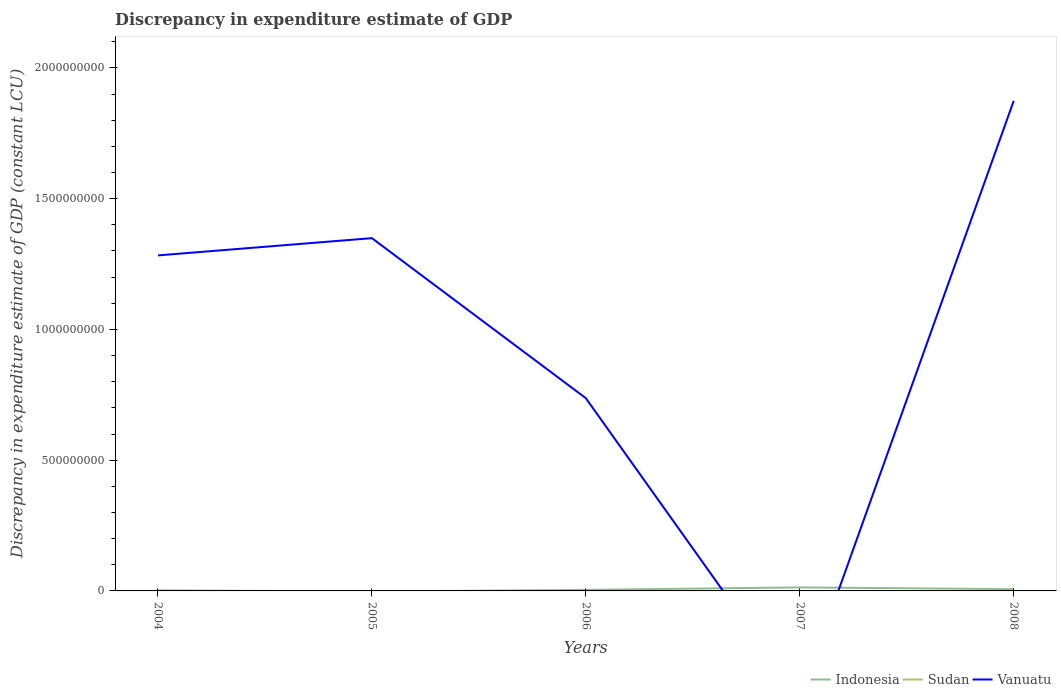Is the number of lines equal to the number of legend labels?
Your answer should be compact. No. Across all years, what is the maximum discrepancy in expenditure estimate of GDP in Sudan?
Keep it short and to the point. 0. What is the total discrepancy in expenditure estimate of GDP in Vanuatu in the graph?
Your answer should be compact. -1.14e+09. What is the difference between the highest and the second highest discrepancy in expenditure estimate of GDP in Vanuatu?
Offer a terse response. 1.87e+09. Is the discrepancy in expenditure estimate of GDP in Sudan strictly greater than the discrepancy in expenditure estimate of GDP in Vanuatu over the years?
Provide a succinct answer. Yes. How many lines are there?
Offer a very short reply. 2. How many years are there in the graph?
Provide a succinct answer. 5. What is the difference between two consecutive major ticks on the Y-axis?
Keep it short and to the point. 5.00e+08. Are the values on the major ticks of Y-axis written in scientific E-notation?
Provide a succinct answer. No. Does the graph contain any zero values?
Your response must be concise. Yes. Does the graph contain grids?
Ensure brevity in your answer.  No. What is the title of the graph?
Keep it short and to the point. Discrepancy in expenditure estimate of GDP. What is the label or title of the Y-axis?
Make the answer very short. Discrepancy in expenditure estimate of GDP (constant LCU). What is the Discrepancy in expenditure estimate of GDP (constant LCU) in Indonesia in 2004?
Give a very brief answer. 2.19e+06. What is the Discrepancy in expenditure estimate of GDP (constant LCU) in Vanuatu in 2004?
Give a very brief answer. 1.28e+09. What is the Discrepancy in expenditure estimate of GDP (constant LCU) of Vanuatu in 2005?
Provide a succinct answer. 1.35e+09. What is the Discrepancy in expenditure estimate of GDP (constant LCU) of Indonesia in 2006?
Offer a terse response. 4.05e+06. What is the Discrepancy in expenditure estimate of GDP (constant LCU) of Sudan in 2006?
Your answer should be very brief. 0. What is the Discrepancy in expenditure estimate of GDP (constant LCU) in Vanuatu in 2006?
Offer a very short reply. 7.37e+08. What is the Discrepancy in expenditure estimate of GDP (constant LCU) in Indonesia in 2007?
Your answer should be compact. 1.35e+07. What is the Discrepancy in expenditure estimate of GDP (constant LCU) in Indonesia in 2008?
Provide a succinct answer. 6.75e+06. What is the Discrepancy in expenditure estimate of GDP (constant LCU) of Sudan in 2008?
Offer a terse response. 0. What is the Discrepancy in expenditure estimate of GDP (constant LCU) in Vanuatu in 2008?
Provide a succinct answer. 1.87e+09. Across all years, what is the maximum Discrepancy in expenditure estimate of GDP (constant LCU) of Indonesia?
Offer a terse response. 1.35e+07. Across all years, what is the maximum Discrepancy in expenditure estimate of GDP (constant LCU) of Vanuatu?
Give a very brief answer. 1.87e+09. Across all years, what is the minimum Discrepancy in expenditure estimate of GDP (constant LCU) in Indonesia?
Provide a succinct answer. 0. What is the total Discrepancy in expenditure estimate of GDP (constant LCU) in Indonesia in the graph?
Your answer should be very brief. 2.65e+07. What is the total Discrepancy in expenditure estimate of GDP (constant LCU) in Sudan in the graph?
Provide a succinct answer. 0. What is the total Discrepancy in expenditure estimate of GDP (constant LCU) in Vanuatu in the graph?
Your answer should be compact. 5.24e+09. What is the difference between the Discrepancy in expenditure estimate of GDP (constant LCU) in Vanuatu in 2004 and that in 2005?
Offer a very short reply. -6.60e+07. What is the difference between the Discrepancy in expenditure estimate of GDP (constant LCU) in Indonesia in 2004 and that in 2006?
Provide a short and direct response. -1.87e+06. What is the difference between the Discrepancy in expenditure estimate of GDP (constant LCU) in Vanuatu in 2004 and that in 2006?
Your answer should be very brief. 5.46e+08. What is the difference between the Discrepancy in expenditure estimate of GDP (constant LCU) of Indonesia in 2004 and that in 2007?
Provide a short and direct response. -1.13e+07. What is the difference between the Discrepancy in expenditure estimate of GDP (constant LCU) of Indonesia in 2004 and that in 2008?
Your answer should be compact. -4.56e+06. What is the difference between the Discrepancy in expenditure estimate of GDP (constant LCU) in Vanuatu in 2004 and that in 2008?
Offer a terse response. -5.91e+08. What is the difference between the Discrepancy in expenditure estimate of GDP (constant LCU) in Vanuatu in 2005 and that in 2006?
Keep it short and to the point. 6.12e+08. What is the difference between the Discrepancy in expenditure estimate of GDP (constant LCU) of Vanuatu in 2005 and that in 2008?
Ensure brevity in your answer.  -5.25e+08. What is the difference between the Discrepancy in expenditure estimate of GDP (constant LCU) in Indonesia in 2006 and that in 2007?
Ensure brevity in your answer.  -9.47e+06. What is the difference between the Discrepancy in expenditure estimate of GDP (constant LCU) of Indonesia in 2006 and that in 2008?
Make the answer very short. -2.70e+06. What is the difference between the Discrepancy in expenditure estimate of GDP (constant LCU) of Vanuatu in 2006 and that in 2008?
Your response must be concise. -1.14e+09. What is the difference between the Discrepancy in expenditure estimate of GDP (constant LCU) of Indonesia in 2007 and that in 2008?
Make the answer very short. 6.78e+06. What is the difference between the Discrepancy in expenditure estimate of GDP (constant LCU) of Indonesia in 2004 and the Discrepancy in expenditure estimate of GDP (constant LCU) of Vanuatu in 2005?
Give a very brief answer. -1.35e+09. What is the difference between the Discrepancy in expenditure estimate of GDP (constant LCU) in Indonesia in 2004 and the Discrepancy in expenditure estimate of GDP (constant LCU) in Vanuatu in 2006?
Ensure brevity in your answer.  -7.35e+08. What is the difference between the Discrepancy in expenditure estimate of GDP (constant LCU) of Indonesia in 2004 and the Discrepancy in expenditure estimate of GDP (constant LCU) of Vanuatu in 2008?
Your response must be concise. -1.87e+09. What is the difference between the Discrepancy in expenditure estimate of GDP (constant LCU) of Indonesia in 2006 and the Discrepancy in expenditure estimate of GDP (constant LCU) of Vanuatu in 2008?
Offer a very short reply. -1.87e+09. What is the difference between the Discrepancy in expenditure estimate of GDP (constant LCU) in Indonesia in 2007 and the Discrepancy in expenditure estimate of GDP (constant LCU) in Vanuatu in 2008?
Make the answer very short. -1.86e+09. What is the average Discrepancy in expenditure estimate of GDP (constant LCU) in Indonesia per year?
Offer a terse response. 5.30e+06. What is the average Discrepancy in expenditure estimate of GDP (constant LCU) of Sudan per year?
Provide a short and direct response. 0. What is the average Discrepancy in expenditure estimate of GDP (constant LCU) of Vanuatu per year?
Your answer should be very brief. 1.05e+09. In the year 2004, what is the difference between the Discrepancy in expenditure estimate of GDP (constant LCU) in Indonesia and Discrepancy in expenditure estimate of GDP (constant LCU) in Vanuatu?
Offer a terse response. -1.28e+09. In the year 2006, what is the difference between the Discrepancy in expenditure estimate of GDP (constant LCU) in Indonesia and Discrepancy in expenditure estimate of GDP (constant LCU) in Vanuatu?
Give a very brief answer. -7.33e+08. In the year 2008, what is the difference between the Discrepancy in expenditure estimate of GDP (constant LCU) in Indonesia and Discrepancy in expenditure estimate of GDP (constant LCU) in Vanuatu?
Provide a succinct answer. -1.87e+09. What is the ratio of the Discrepancy in expenditure estimate of GDP (constant LCU) in Vanuatu in 2004 to that in 2005?
Give a very brief answer. 0.95. What is the ratio of the Discrepancy in expenditure estimate of GDP (constant LCU) in Indonesia in 2004 to that in 2006?
Your answer should be compact. 0.54. What is the ratio of the Discrepancy in expenditure estimate of GDP (constant LCU) in Vanuatu in 2004 to that in 2006?
Your answer should be very brief. 1.74. What is the ratio of the Discrepancy in expenditure estimate of GDP (constant LCU) in Indonesia in 2004 to that in 2007?
Your answer should be very brief. 0.16. What is the ratio of the Discrepancy in expenditure estimate of GDP (constant LCU) of Indonesia in 2004 to that in 2008?
Provide a succinct answer. 0.32. What is the ratio of the Discrepancy in expenditure estimate of GDP (constant LCU) in Vanuatu in 2004 to that in 2008?
Make the answer very short. 0.68. What is the ratio of the Discrepancy in expenditure estimate of GDP (constant LCU) in Vanuatu in 2005 to that in 2006?
Offer a very short reply. 1.83. What is the ratio of the Discrepancy in expenditure estimate of GDP (constant LCU) of Vanuatu in 2005 to that in 2008?
Offer a very short reply. 0.72. What is the ratio of the Discrepancy in expenditure estimate of GDP (constant LCU) in Indonesia in 2006 to that in 2007?
Provide a short and direct response. 0.3. What is the ratio of the Discrepancy in expenditure estimate of GDP (constant LCU) of Indonesia in 2006 to that in 2008?
Keep it short and to the point. 0.6. What is the ratio of the Discrepancy in expenditure estimate of GDP (constant LCU) of Vanuatu in 2006 to that in 2008?
Provide a short and direct response. 0.39. What is the ratio of the Discrepancy in expenditure estimate of GDP (constant LCU) of Indonesia in 2007 to that in 2008?
Give a very brief answer. 2. What is the difference between the highest and the second highest Discrepancy in expenditure estimate of GDP (constant LCU) of Indonesia?
Your answer should be very brief. 6.78e+06. What is the difference between the highest and the second highest Discrepancy in expenditure estimate of GDP (constant LCU) of Vanuatu?
Provide a short and direct response. 5.25e+08. What is the difference between the highest and the lowest Discrepancy in expenditure estimate of GDP (constant LCU) in Indonesia?
Ensure brevity in your answer.  1.35e+07. What is the difference between the highest and the lowest Discrepancy in expenditure estimate of GDP (constant LCU) of Vanuatu?
Provide a succinct answer. 1.87e+09. 